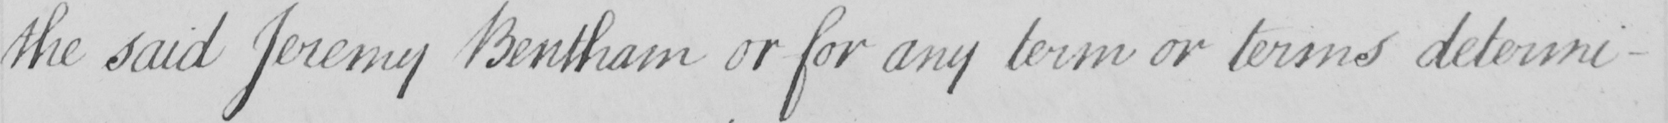Transcribe the text shown in this historical manuscript line. the said Jeremy Bentham or for any term or terms determi- 